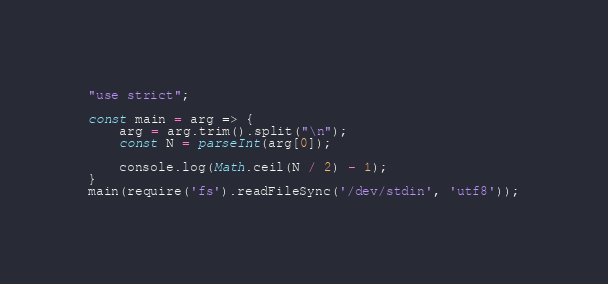Convert code to text. <code><loc_0><loc_0><loc_500><loc_500><_JavaScript_>"use strict";
    
const main = arg => {
    arg = arg.trim().split("\n");
    const N = parseInt(arg[0]);
    
    console.log(Math.ceil(N / 2) - 1);
}
main(require('fs').readFileSync('/dev/stdin', 'utf8'));</code> 